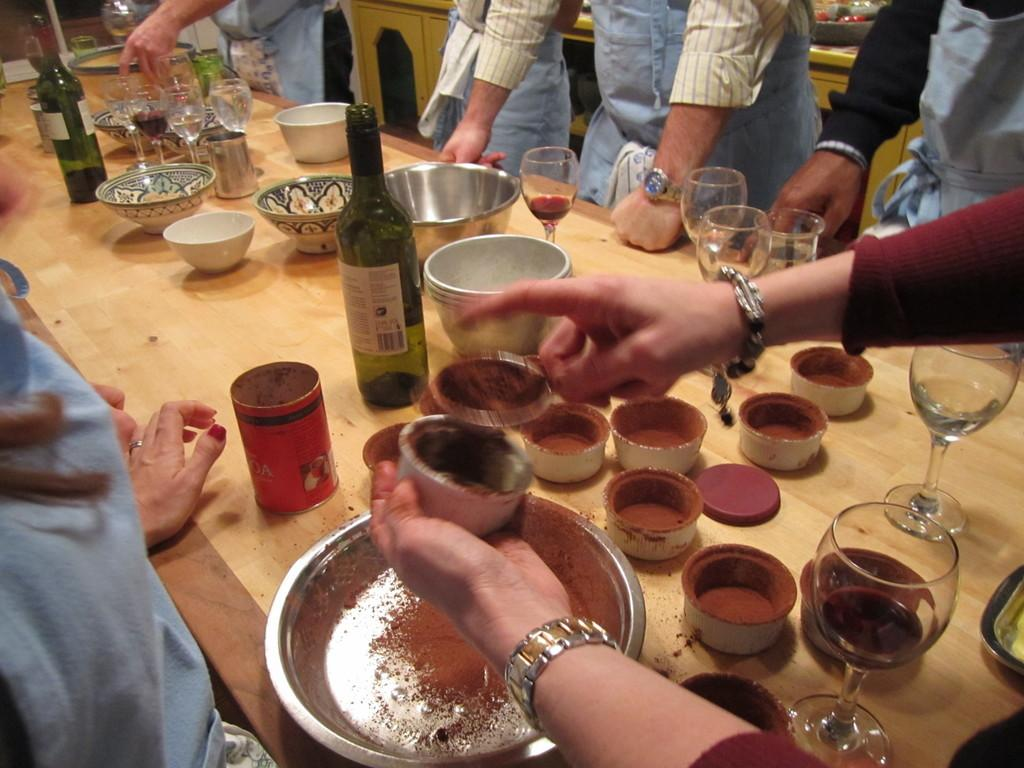How many people are in the image? There is a group of people in the image. What are the people doing in the image? The people are standing. What objects can be seen on the table in the image? There are glasses, bottles, and bowls on the table in the image. What can be seen in the background of the image? There are cupboards in the background of the image. What type of snow can be seen falling in the image? There is no snow present in the image. What kind of tub is visible in the image? There is no tub present in the image. 